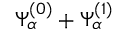<formula> <loc_0><loc_0><loc_500><loc_500>\Psi _ { \alpha } ^ { ( 0 ) } + \Psi _ { \alpha } ^ { ( 1 ) }</formula> 